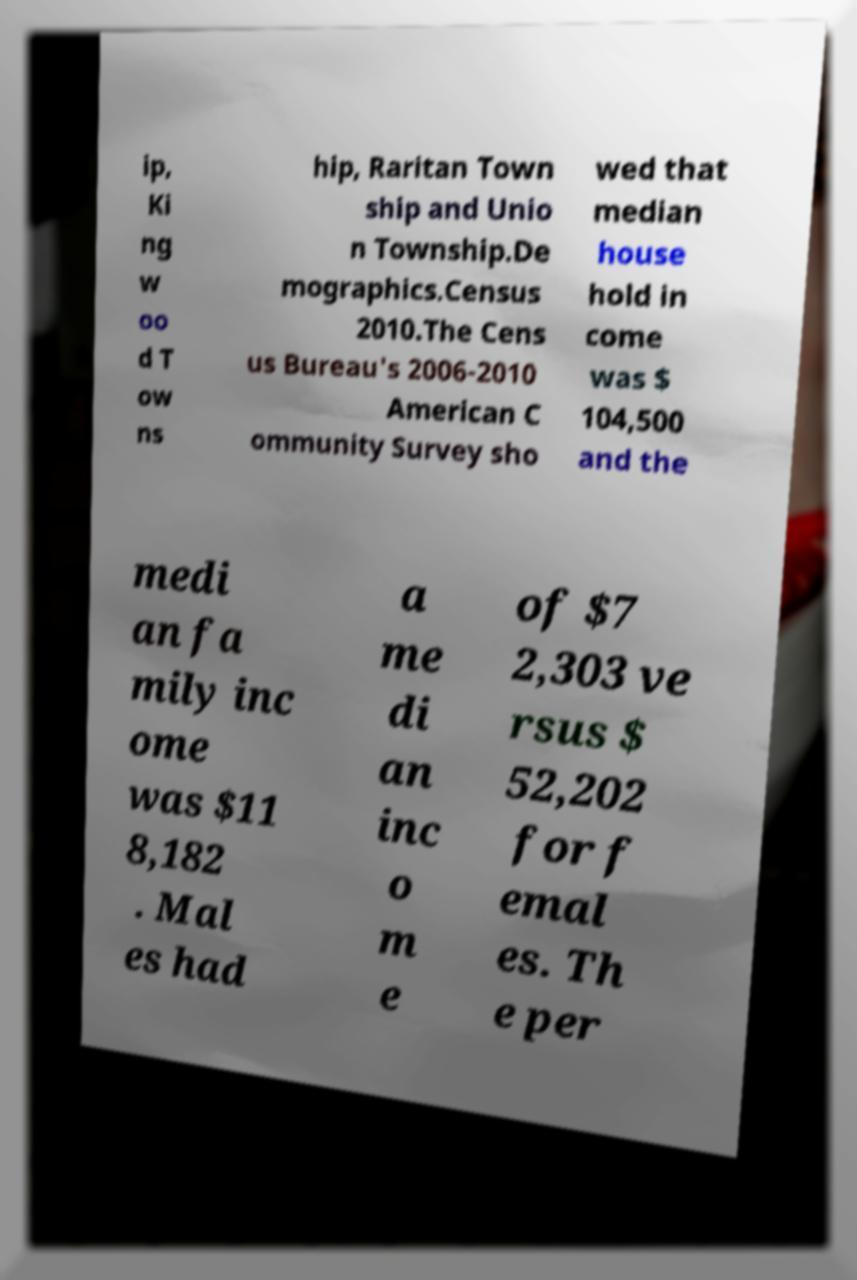Please read and relay the text visible in this image. What does it say? ip, Ki ng w oo d T ow ns hip, Raritan Town ship and Unio n Township.De mographics.Census 2010.The Cens us Bureau's 2006-2010 American C ommunity Survey sho wed that median house hold in come was $ 104,500 and the medi an fa mily inc ome was $11 8,182 . Mal es had a me di an inc o m e of $7 2,303 ve rsus $ 52,202 for f emal es. Th e per 